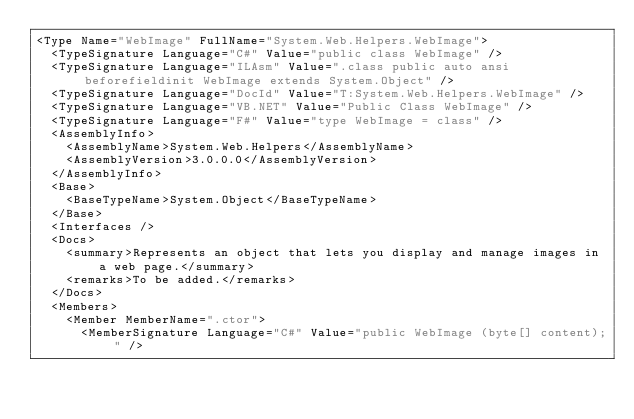Convert code to text. <code><loc_0><loc_0><loc_500><loc_500><_XML_><Type Name="WebImage" FullName="System.Web.Helpers.WebImage">
  <TypeSignature Language="C#" Value="public class WebImage" />
  <TypeSignature Language="ILAsm" Value=".class public auto ansi beforefieldinit WebImage extends System.Object" />
  <TypeSignature Language="DocId" Value="T:System.Web.Helpers.WebImage" />
  <TypeSignature Language="VB.NET" Value="Public Class WebImage" />
  <TypeSignature Language="F#" Value="type WebImage = class" />
  <AssemblyInfo>
    <AssemblyName>System.Web.Helpers</AssemblyName>
    <AssemblyVersion>3.0.0.0</AssemblyVersion>
  </AssemblyInfo>
  <Base>
    <BaseTypeName>System.Object</BaseTypeName>
  </Base>
  <Interfaces />
  <Docs>
    <summary>Represents an object that lets you display and manage images in a web page.</summary>
    <remarks>To be added.</remarks>
  </Docs>
  <Members>
    <Member MemberName=".ctor">
      <MemberSignature Language="C#" Value="public WebImage (byte[] content);" /></code> 